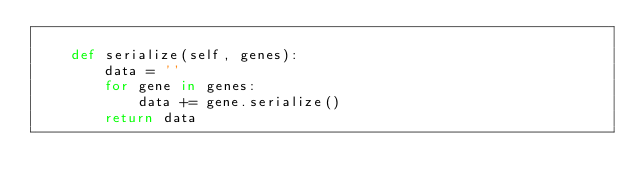<code> <loc_0><loc_0><loc_500><loc_500><_Python_>
    def serialize(self, genes):
        data = ''
        for gene in genes:
            data += gene.serialize()
        return data
</code> 